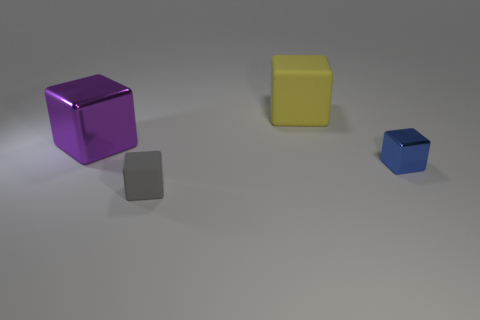Are there fewer tiny matte blocks that are behind the big metallic block than small shiny blocks?
Your response must be concise. Yes. How many things are either tiny matte cubes or big cubes on the left side of the large matte cube?
Ensure brevity in your answer.  2. There is a large cube that is the same material as the small blue thing; what color is it?
Your response must be concise. Purple. How many objects are tiny yellow matte spheres or large things?
Give a very brief answer. 2. There is another object that is the same size as the blue metal thing; what color is it?
Keep it short and to the point. Gray. How many things are either rubber blocks in front of the small blue block or tiny blue metal things?
Provide a succinct answer. 2. What number of other things are there of the same size as the yellow object?
Your response must be concise. 1. There is a rubber thing in front of the purple shiny block; what is its size?
Your response must be concise. Small. There is another tiny object that is the same material as the purple object; what shape is it?
Provide a short and direct response. Cube. Is there anything else that has the same color as the big metal block?
Your response must be concise. No. 